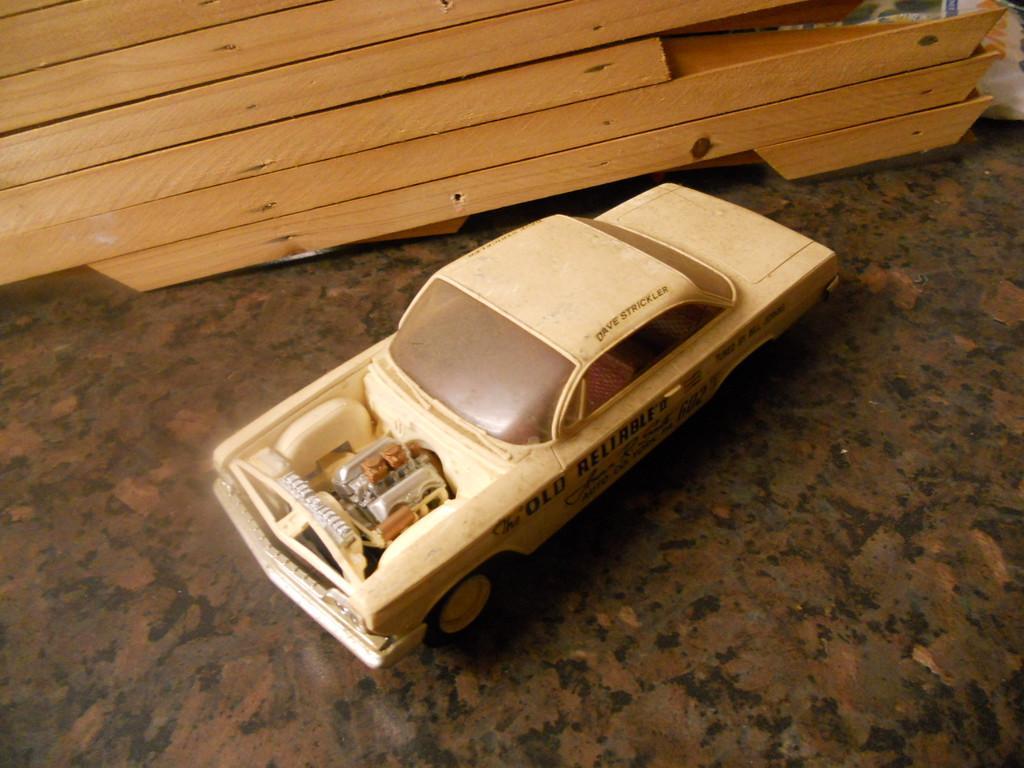How would you summarize this image in a sentence or two? In this picture there is Buick wildcat in the center of the image and there are wooden boards at the top side of the image. 